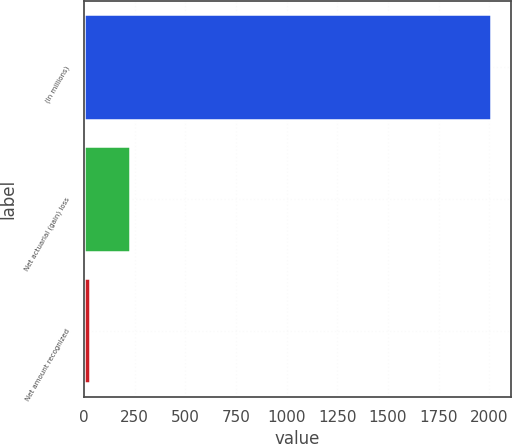Convert chart to OTSL. <chart><loc_0><loc_0><loc_500><loc_500><bar_chart><fcel>(In millions)<fcel>Net actuarial (gain) loss<fcel>Net amount recognized<nl><fcel>2008<fcel>228.52<fcel>30.8<nl></chart> 